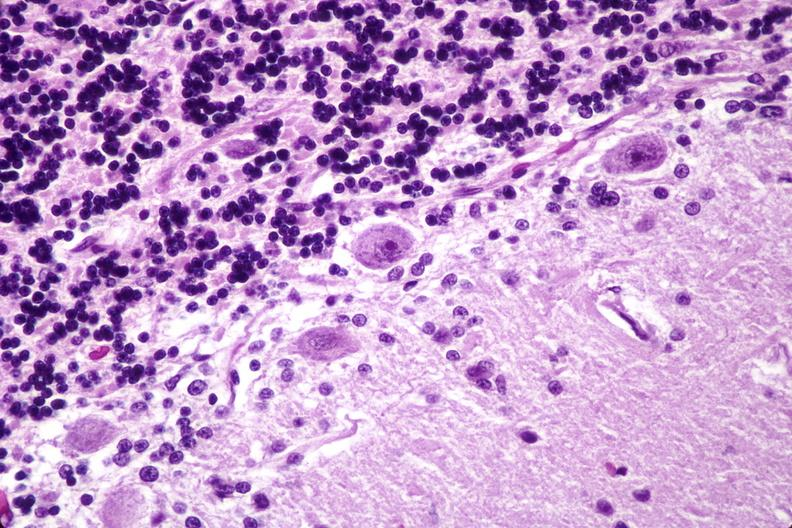does premature coronary disease show brain lymphoma?
Answer the question using a single word or phrase. No 